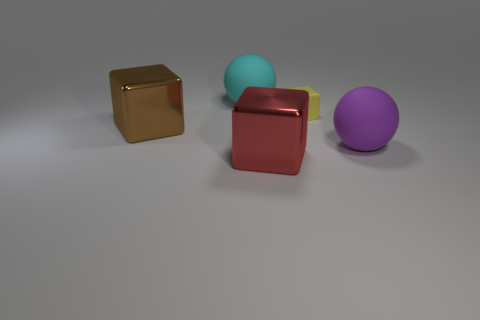Add 2 metallic blocks. How many objects exist? 7 Subtract all cubes. How many objects are left? 2 Add 4 brown shiny objects. How many brown shiny objects are left? 5 Add 3 brown metallic things. How many brown metallic things exist? 4 Subtract 1 red cubes. How many objects are left? 4 Subtract all large metal blocks. Subtract all big metallic things. How many objects are left? 1 